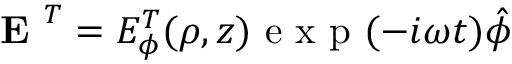<formula> <loc_0><loc_0><loc_500><loc_500>E ^ { T } = E _ { \phi } ^ { T } ( \rho , z ) e x p ( - i \omega t ) \hat { \phi }</formula> 